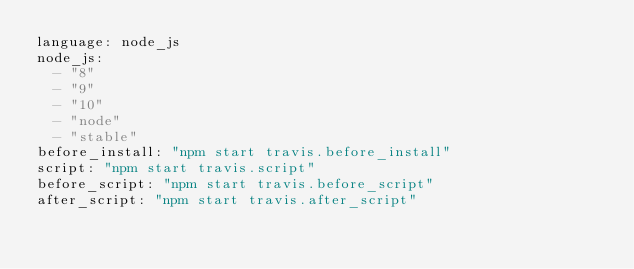Convert code to text. <code><loc_0><loc_0><loc_500><loc_500><_YAML_>language: node_js
node_js:
  - "8"
  - "9"
  - "10"
  - "node"
  - "stable"
before_install: "npm start travis.before_install"
script: "npm start travis.script"
before_script: "npm start travis.before_script"
after_script: "npm start travis.after_script"
</code> 